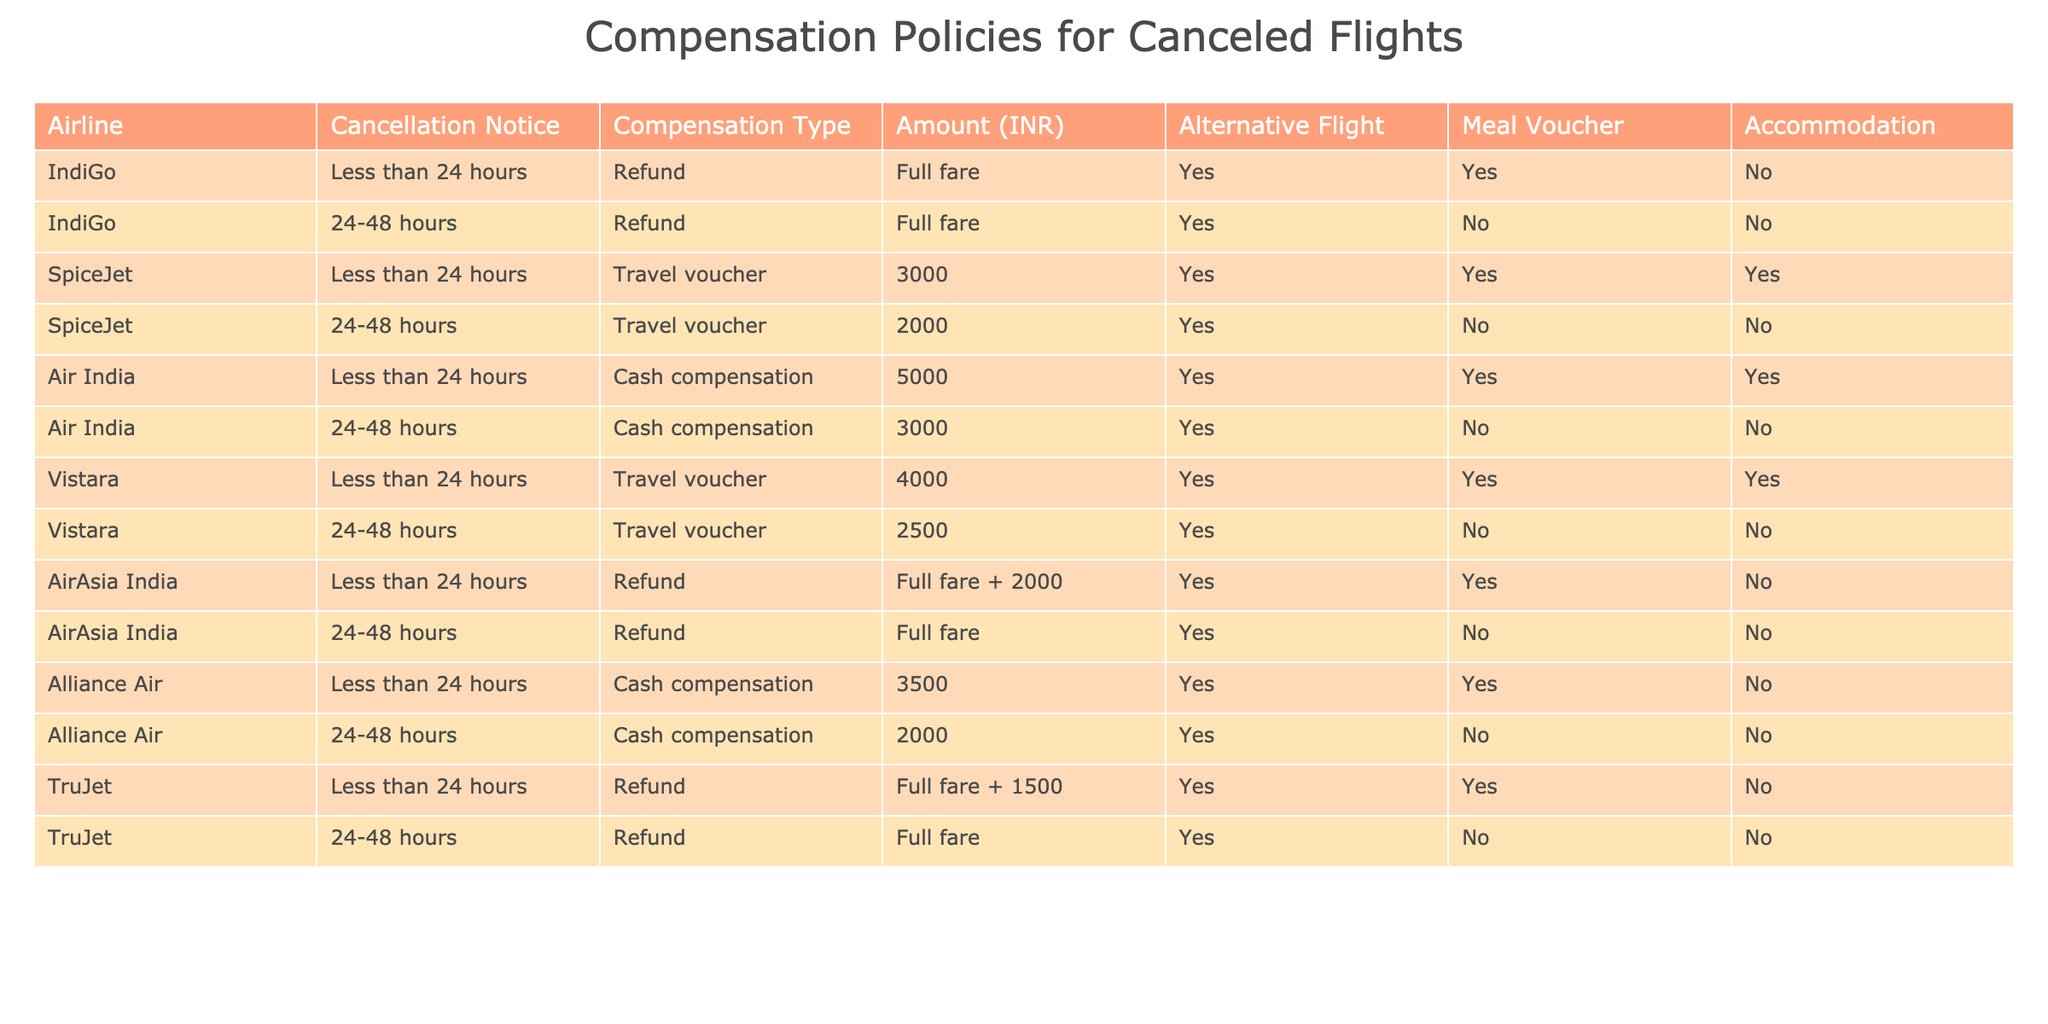What is the compensation type for canceled flights by Air India with less than 24 hours notice? The table indicates that Air India offers cash compensation for canceled flights with less than 24 hours notice.
Answer: Cash compensation Which airline provides a meal voucher for cancellations made less than 24 hours in advance? Looking at the table, Air India, SpiceJet, Vistara, and Alliance Air all provide meal vouchers for cancellations made less than 24 hours in advance.
Answer: Air India, SpiceJet, Vistara, Alliance Air What is the amount of compensation offered by SpiceJet for cancellations made 24-48 hours in advance? From the table, it shows that SpiceJet offers a travel voucher amounting to 2000 INR for cancellations made 24-48 hours in advance.
Answer: 2000 INR Is it true that TruJet offers full fare refund for flight cancellations made less than 24 hours in advance? Referring to the table, it states that TruJet offers a refund of full fare plus an additional 1500 INR for cancellations made less than 24 hours in advance, thus it does not strictly offer a full fare refund.
Answer: No What is the average compensation amount for all airlines for cancellations made within 24-48 hours? To find the average, the compensation amounts for cancellations within the time frame need to be calculated: IndiGo (Full fare, treated as 0), SpiceJet (2000), Air India (3000), Vistara (2500), AirAsia India (Full fare, treated as 0), Alliance Air (2000), and TruJet (Full fare, treated as 0). The total for specific values is 2000 + 3000 + 2500 + 2000 = 9500. There are four data points here: 9500 / 4 = 2375.
Answer: 2375 Which airline does not provide accommodation for cancellations made within 24-48 hours? By reviewing the table, it can be seen that IndiGo, SpiceJet, Vistara, AirAsia India, and TruJet do not provide accommodation for cancellations made within 24-48 hours.
Answer: IndiGo, SpiceJet, Vistara, AirAsia India, TruJet 